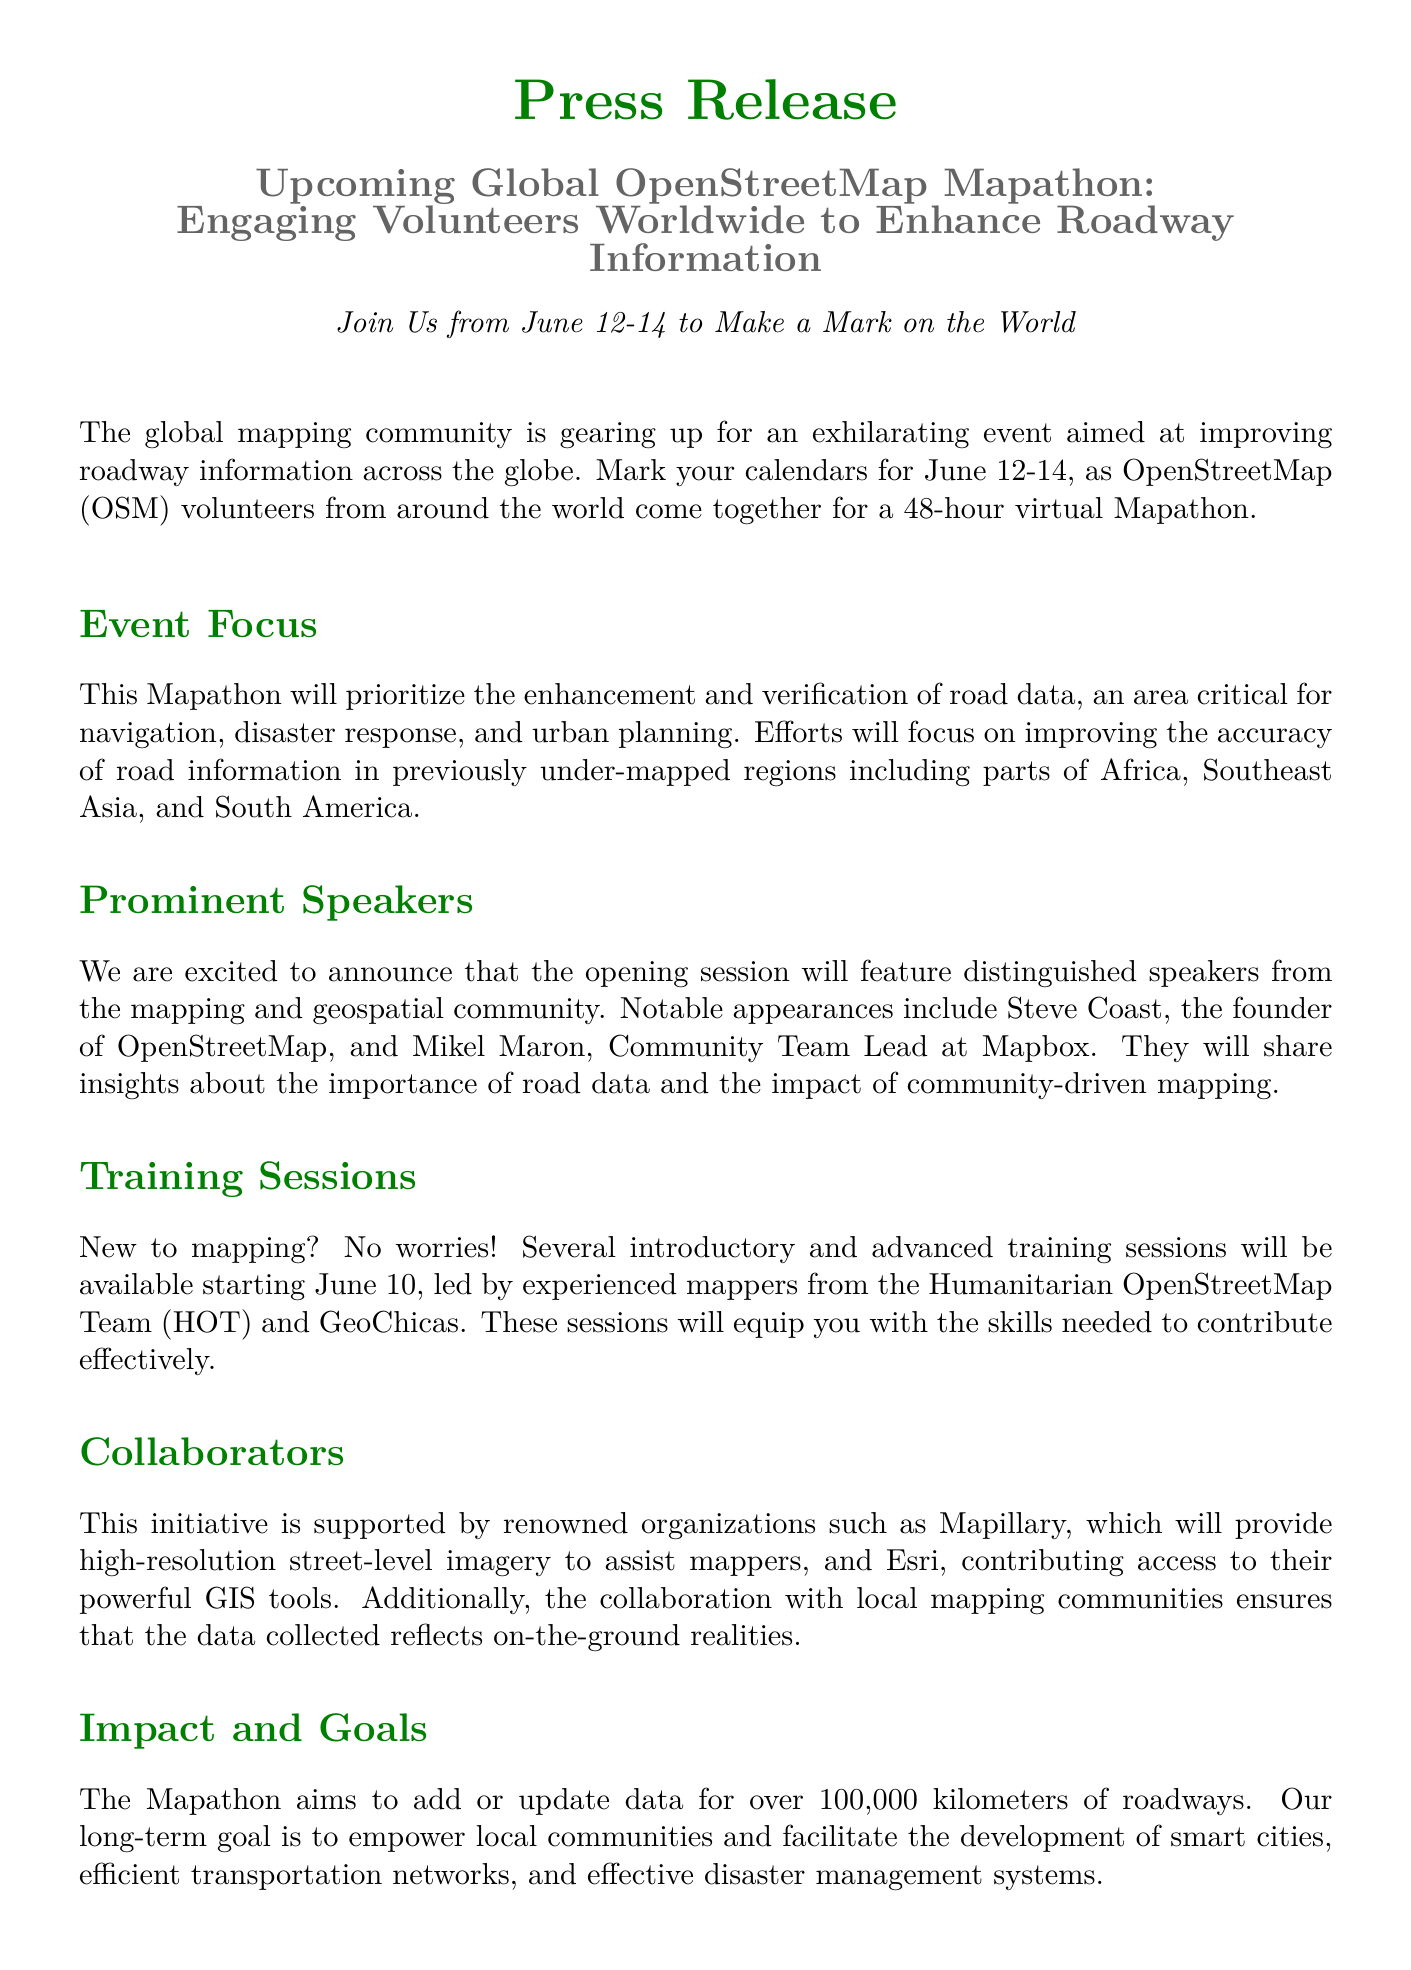What are the dates of the Mapathon? The document specifies that the Mapathon will take place from June 12-14.
Answer: June 12-14 Who is the founder of OpenStreetMap? The document mentions that Steve Coast is the founder of OpenStreetMap.
Answer: Steve Coast What is the target of the Mapathon in terms of roadway data? The goal mentioned in the document is to add or update data for over 100,000 kilometers of roadways.
Answer: 100,000 kilometers Which organizations are collaborating on this initiative? The document lists Mapillary and Esri as renowned organizations collaborating for the Mapathon.
Answer: Mapillary and Esri When will training sessions start? According to the document, the training sessions will begin starting June 10.
Answer: June 10 What is the main focus of the Mapathon? The document states that the focus is on the enhancement and verification of road data.
Answer: Enhancement and verification of road data Who is the Community Team Lead at Mapbox? Mikel Maron is identified as the Community Team Lead at Mapbox in the document.
Answer: Mikel Maron What is the (long-term) goal of the Mapathon? The document outlines the long-term goal as empowering local communities for smart city development and disaster management.
Answer: Empower local communities and facilitate development of smart cities and disaster management 